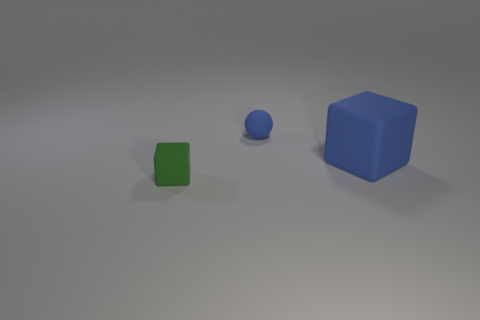Subtract all cubes. How many objects are left? 1 Add 3 small things. How many small things exist? 5 Add 2 large rubber things. How many objects exist? 5 Subtract all blue cubes. How many cubes are left? 1 Subtract 1 blue cubes. How many objects are left? 2 Subtract 1 spheres. How many spheres are left? 0 Subtract all cyan cubes. Subtract all blue balls. How many cubes are left? 2 Subtract all purple cylinders. How many green balls are left? 0 Subtract all small red balls. Subtract all small rubber spheres. How many objects are left? 2 Add 1 blue rubber cubes. How many blue rubber cubes are left? 2 